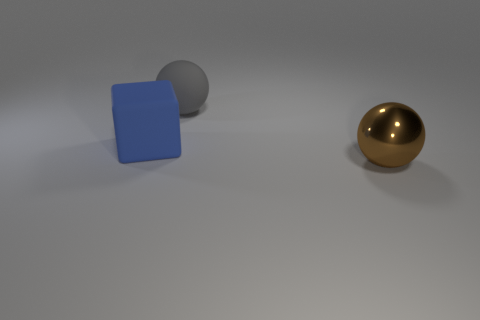Are there any big metal objects?
Keep it short and to the point. Yes. There is another object that is the same shape as the big brown object; what is its color?
Your answer should be compact. Gray. There is a block that is the same size as the metal object; what is its color?
Offer a very short reply. Blue. Are the gray object and the blue thing made of the same material?
Provide a short and direct response. Yes. What number of other large cubes are the same color as the big block?
Offer a terse response. 0. Does the large metallic ball have the same color as the big matte block?
Make the answer very short. No. There is a ball that is behind the big metallic thing; what material is it?
Ensure brevity in your answer.  Rubber. What number of big things are yellow objects or gray objects?
Your answer should be compact. 1. Are there any big blue objects that have the same material as the large gray ball?
Give a very brief answer. Yes. There is a ball behind the brown metallic sphere; does it have the same size as the blue matte object?
Your response must be concise. Yes. 